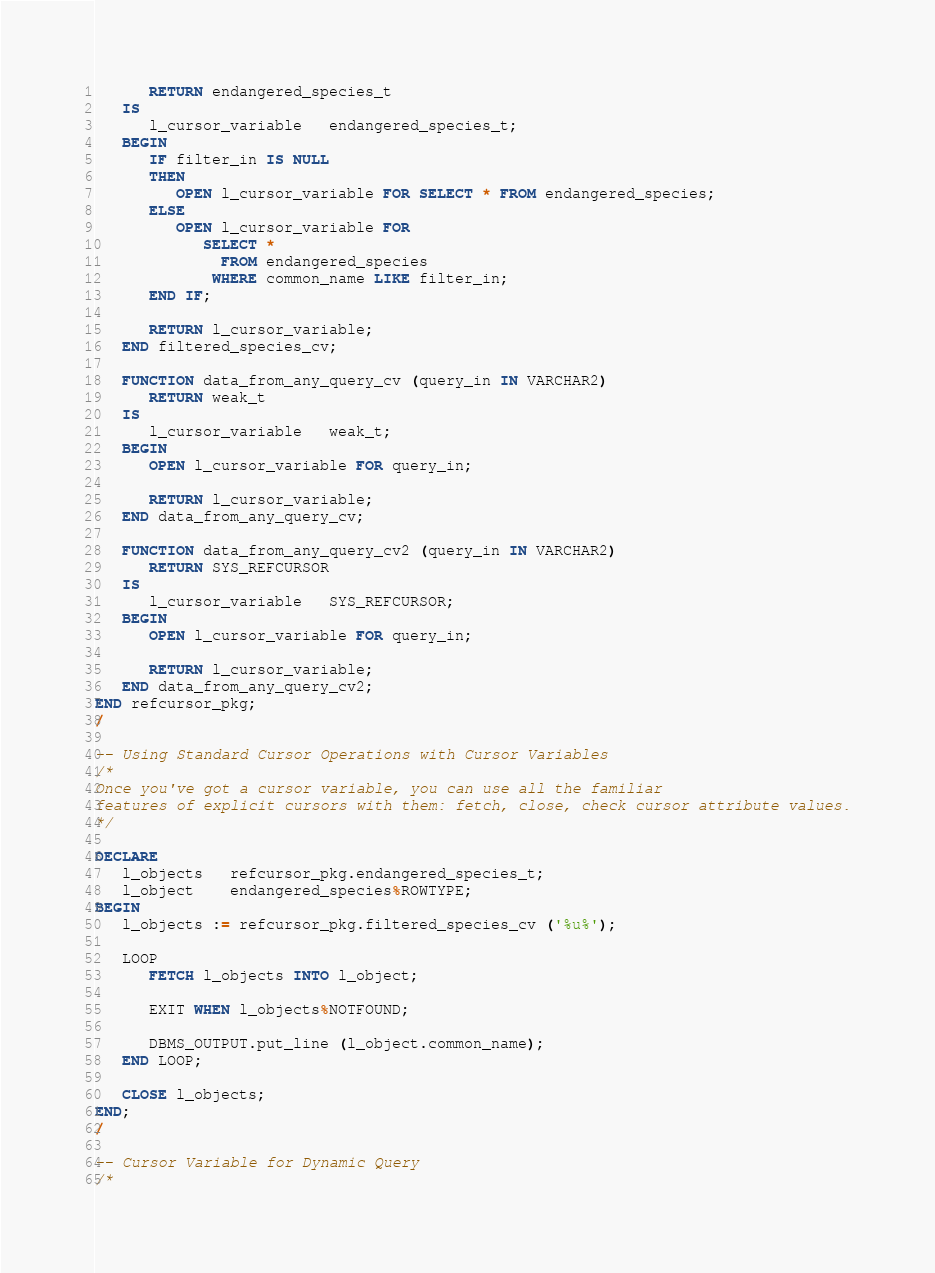<code> <loc_0><loc_0><loc_500><loc_500><_SQL_>      RETURN endangered_species_t 
   IS 
      l_cursor_variable   endangered_species_t; 
   BEGIN 
      IF filter_in IS NULL 
      THEN 
         OPEN l_cursor_variable FOR SELECT * FROM endangered_species; 
      ELSE 
         OPEN l_cursor_variable FOR 
            SELECT * 
              FROM endangered_species 
             WHERE common_name LIKE filter_in; 
      END IF; 
 
      RETURN l_cursor_variable; 
   END filtered_species_cv; 
 
   FUNCTION data_from_any_query_cv (query_in IN VARCHAR2) 
      RETURN weak_t 
   IS 
      l_cursor_variable   weak_t; 
   BEGIN 
      OPEN l_cursor_variable FOR query_in; 
 
      RETURN l_cursor_variable; 
   END data_from_any_query_cv; 
 
   FUNCTION data_from_any_query_cv2 (query_in IN VARCHAR2) 
      RETURN SYS_REFCURSOR 
   IS 
      l_cursor_variable   SYS_REFCURSOR; 
   BEGIN 
      OPEN l_cursor_variable FOR query_in; 
 
      RETURN l_cursor_variable; 
   END data_from_any_query_cv2; 
END refcursor_pkg;
/

-- Using Standard Cursor Operations with Cursor Variables
/*
Once you've got a cursor variable, you can use all the familiar 
features of explicit cursors with them: fetch, close, check cursor attribute values.
*/

DECLARE 
   l_objects   refcursor_pkg.endangered_species_t; 
   l_object    endangered_species%ROWTYPE; 
BEGIN 
   l_objects := refcursor_pkg.filtered_species_cv ('%u%'); 
 
   LOOP 
      FETCH l_objects INTO l_object; 
 
      EXIT WHEN l_objects%NOTFOUND; 
 
      DBMS_OUTPUT.put_line (l_object.common_name); 
   END LOOP; 
 
   CLOSE l_objects; 
END;
/

-- Cursor Variable for Dynamic Query
/*</code> 